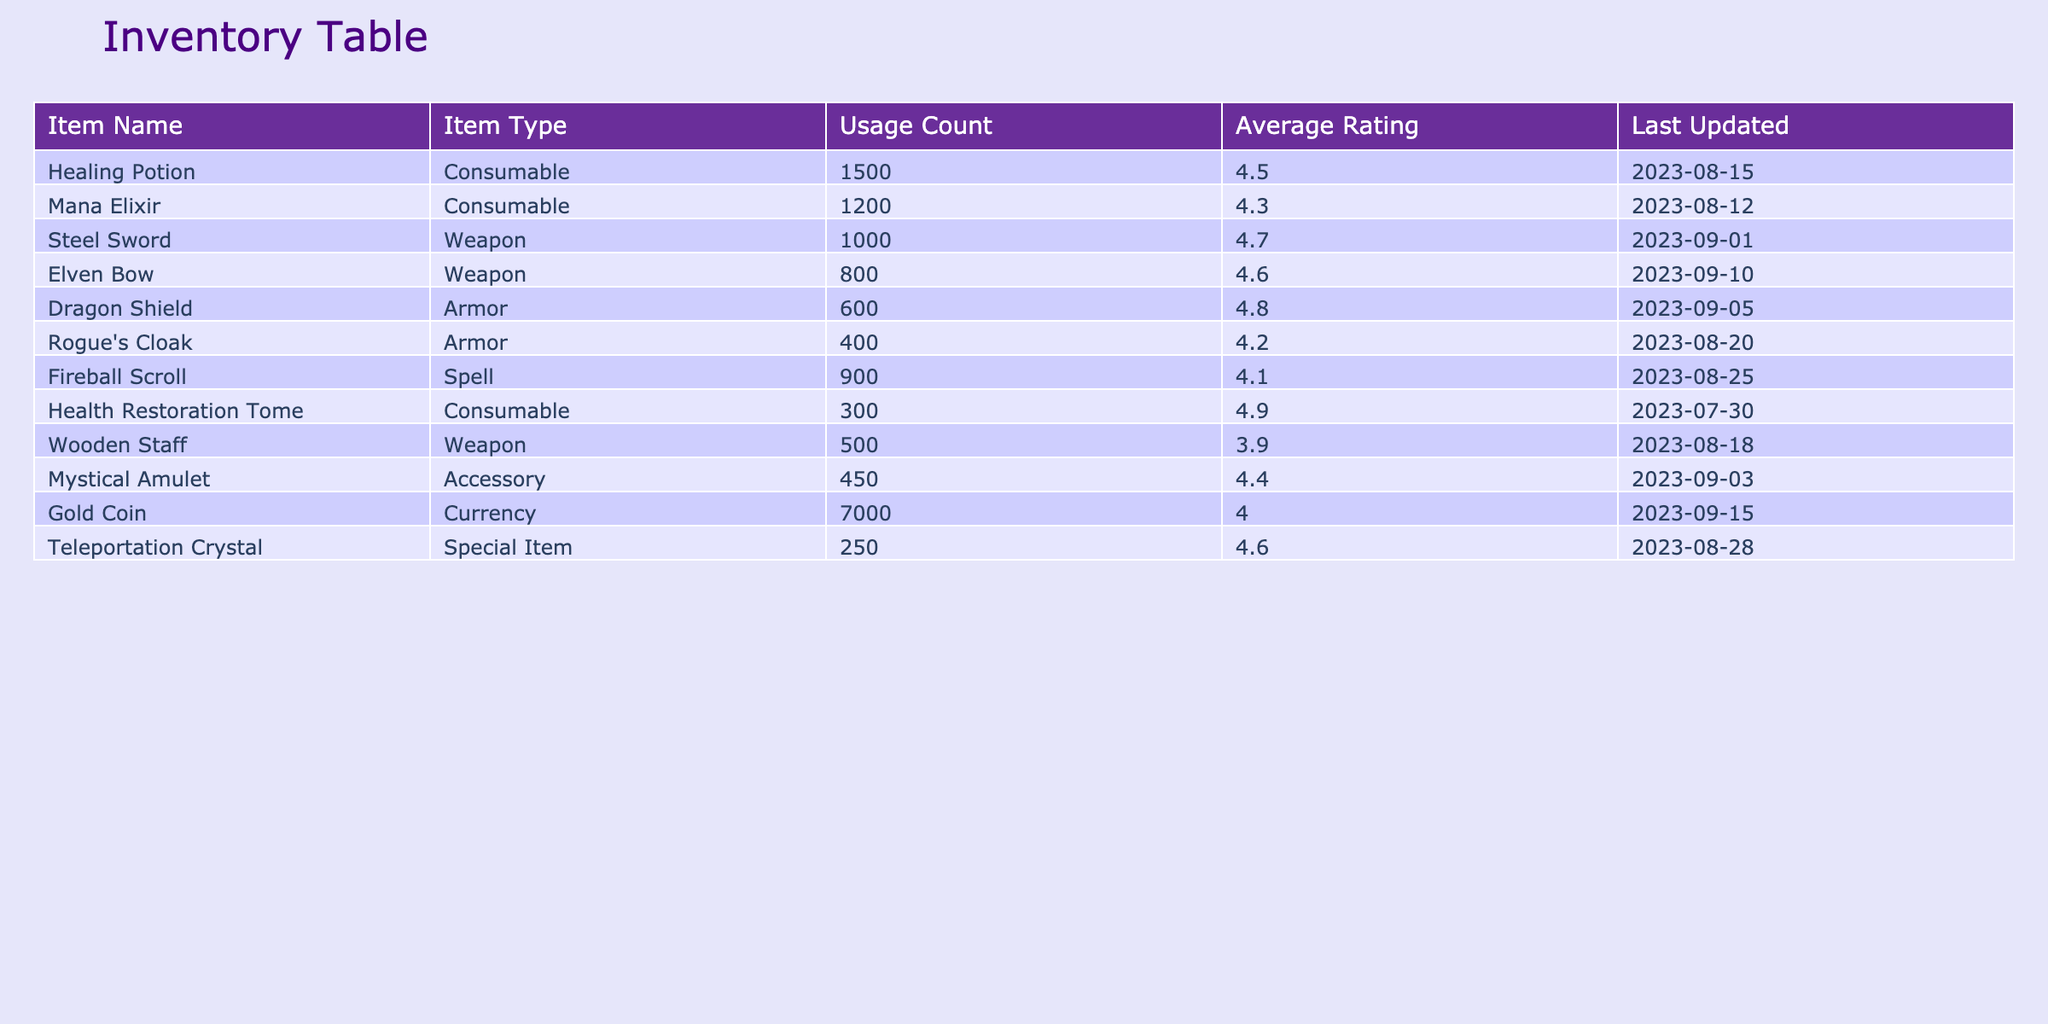What is the highest average rating among the items? By examining the "Average Rating" column, the highest value is found for the "Health Restoration Tome" with a rating of 4.9.
Answer: 4.9 How many items are categorized as consumables? Looking at the "Item Type" column, "Healing Potion," "Mana Elixir," and "Health Restoration Tome" are marked as consumables, totaling three items.
Answer: 3 Is the Steel Sword rated higher than the Elven Bow? The Steel Sword has an average rating of 4.7, while the Elven Bow has a rating of 4.6, indicating that the Steel Sword is rated higher.
Answer: Yes What is the total usage count of all weapons? The total usage count for weapons includes the Steel Sword (1000), Elven Bow (800), and Wooden Staff (500). Summing these (1000 + 800 + 500) results in a total of 2300.
Answer: 2300 Which item has the lowest usage count, and what is that count? Among all items in the "Usage Count" column, the "Teleportation Crystal" has the lowest count of 250.
Answer: Teleportation Crystal, 250 What is the difference in average rating between the Dragon Shield and the Rogue's Cloak? The average rating for the Dragon Shield is 4.8, while the Rogue's Cloak is rated at 4.2. The difference can be calculated as 4.8 - 4.2 = 0.6.
Answer: 0.6 Are there more consumable items than weapon items? There are three consumable items (Healing Potion, Mana Elixir, Health Restoration Tome) and three weapon items (Steel Sword, Elven Bow, Wooden Staff), which means they are equal.
Answer: No What is the average rating of consumable items? To find the average rating for consumables, take the ratings of the Healing Potion (4.5), Mana Elixir (4.3), and Health Restoration Tome (4.9), which sum to 4.5 + 4.3 + 4.9 = 13.7. Dividing by 3 gives an average of 13.7/3 ≈ 4.57.
Answer: 4.57 